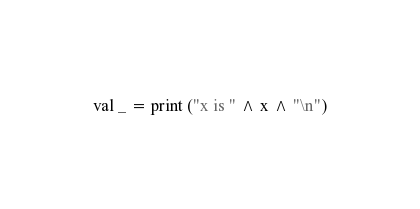Convert code to text. <code><loc_0><loc_0><loc_500><loc_500><_SML_>val _ = print ("x is " ^ x ^ "\n")
</code> 